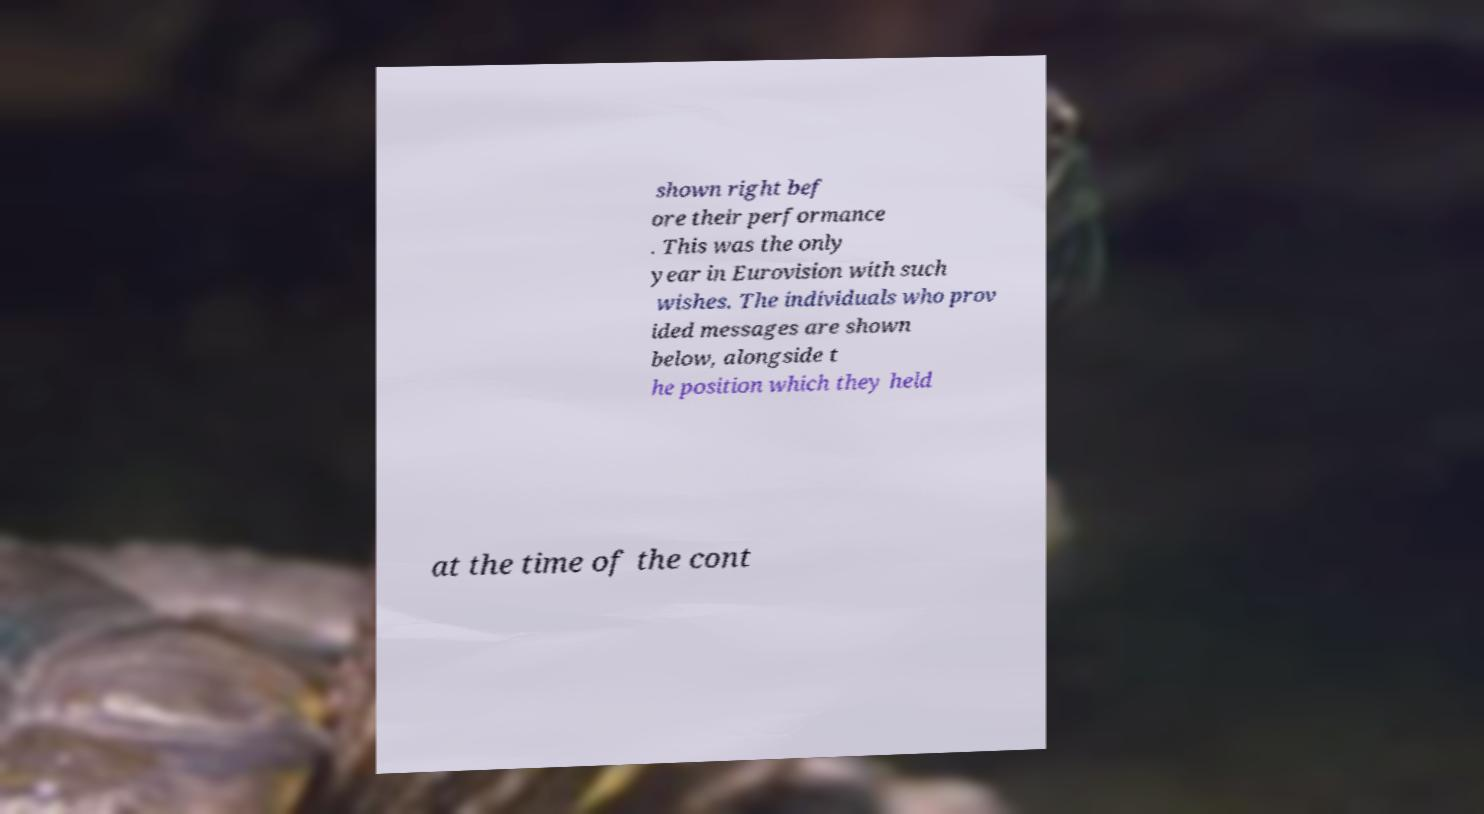Please identify and transcribe the text found in this image. shown right bef ore their performance . This was the only year in Eurovision with such wishes. The individuals who prov ided messages are shown below, alongside t he position which they held at the time of the cont 